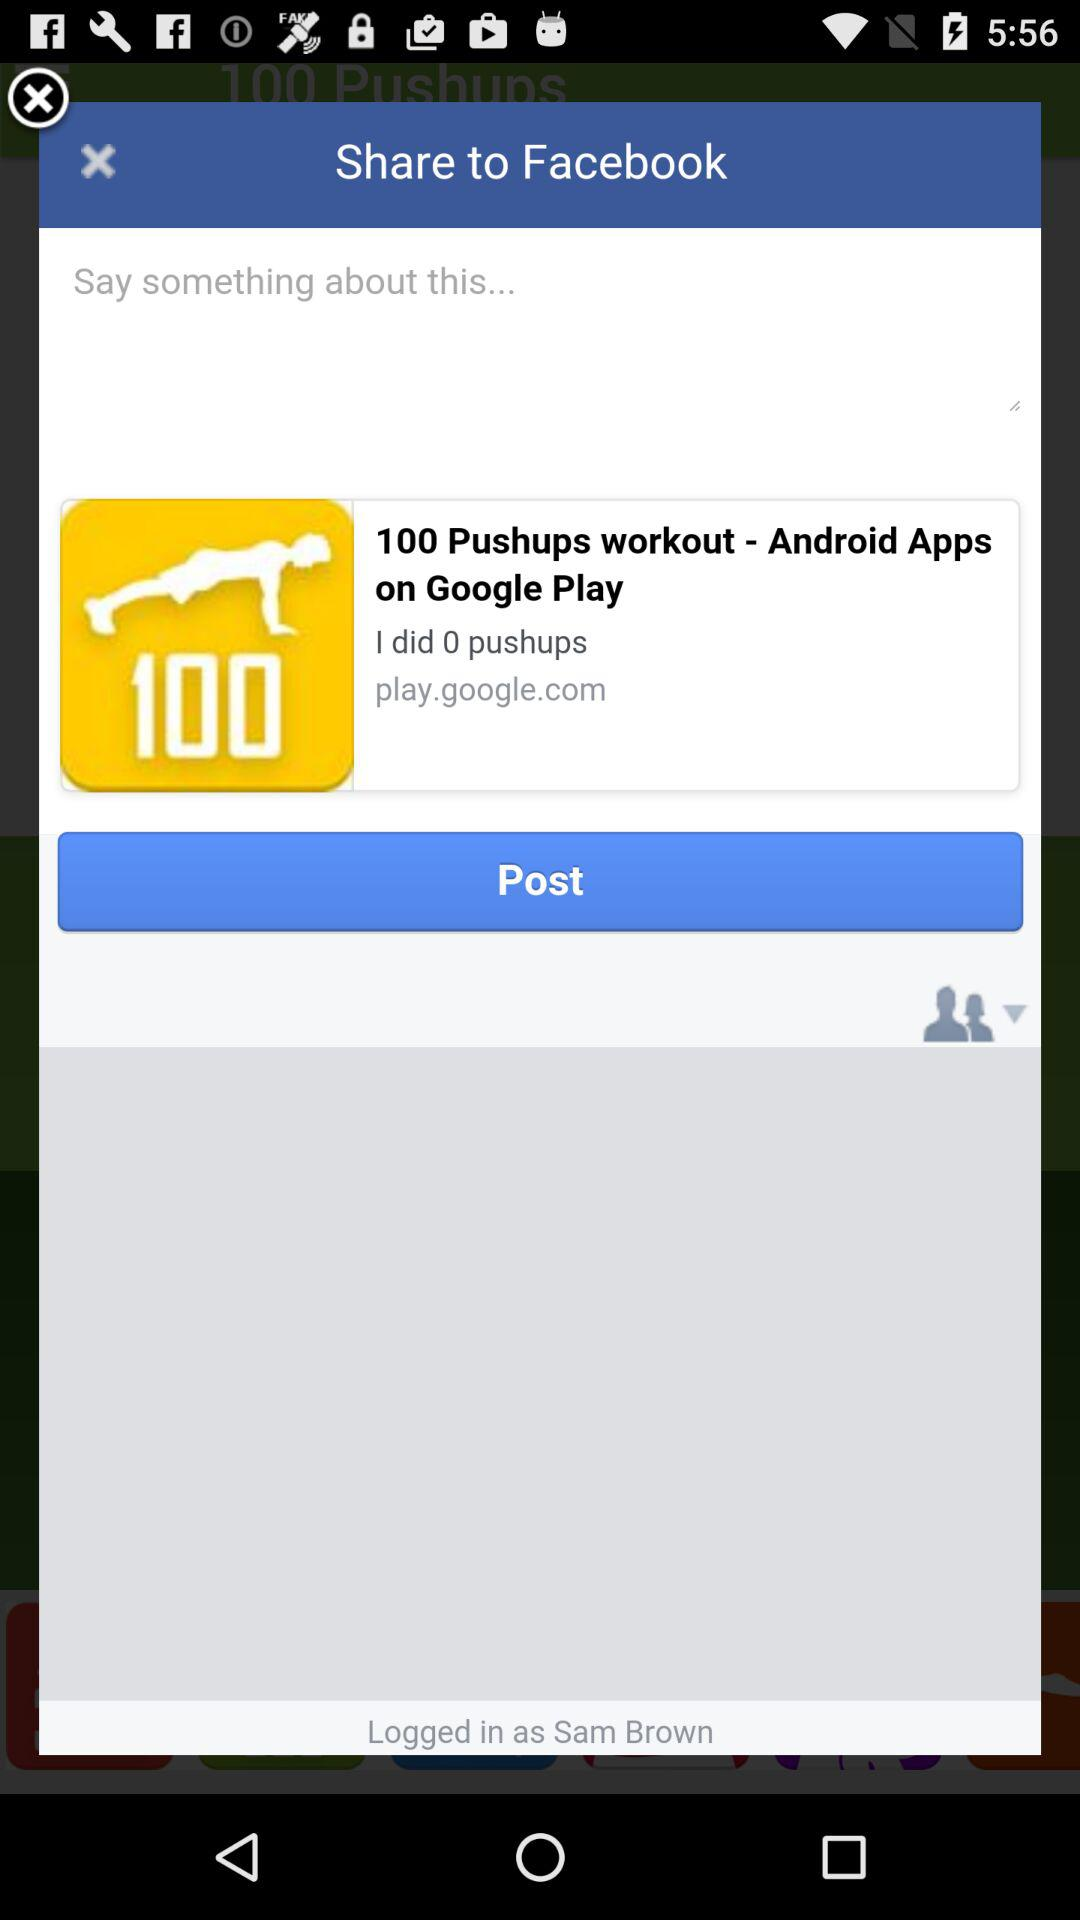How many more pushups do I need to do to complete this workout?
Answer the question using a single word or phrase. 100 